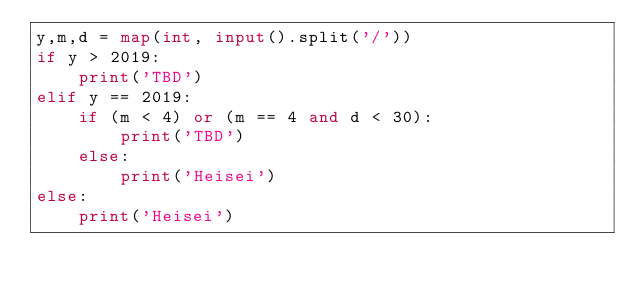<code> <loc_0><loc_0><loc_500><loc_500><_Python_>y,m,d = map(int, input().split('/'))
if y > 2019:
    print('TBD')
elif y == 2019:
    if (m < 4) or (m == 4 and d < 30):
        print('TBD')
    else:
        print('Heisei')
else:
    print('Heisei')
</code> 